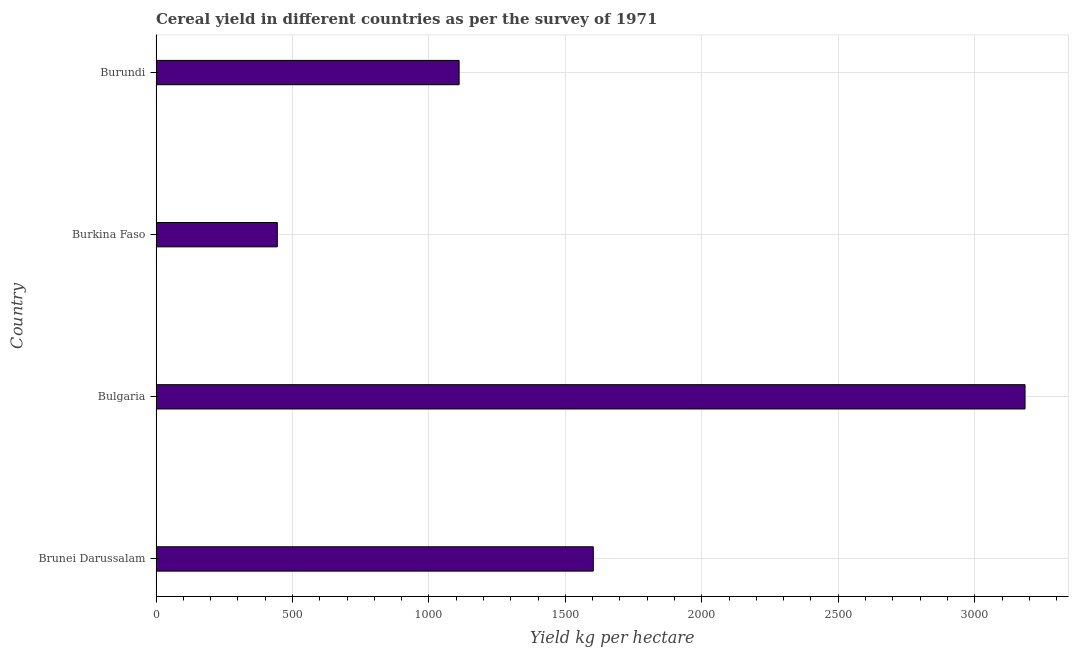Does the graph contain any zero values?
Give a very brief answer. No. What is the title of the graph?
Your answer should be compact. Cereal yield in different countries as per the survey of 1971. What is the label or title of the X-axis?
Ensure brevity in your answer.  Yield kg per hectare. What is the label or title of the Y-axis?
Your answer should be compact. Country. What is the cereal yield in Burkina Faso?
Offer a terse response. 444.45. Across all countries, what is the maximum cereal yield?
Offer a very short reply. 3184.4. Across all countries, what is the minimum cereal yield?
Your answer should be compact. 444.45. In which country was the cereal yield minimum?
Offer a terse response. Burkina Faso. What is the sum of the cereal yield?
Give a very brief answer. 6341.92. What is the difference between the cereal yield in Brunei Darussalam and Burkina Faso?
Give a very brief answer. 1157.96. What is the average cereal yield per country?
Provide a short and direct response. 1585.48. What is the median cereal yield?
Your answer should be compact. 1356.54. In how many countries, is the cereal yield greater than 200 kg per hectare?
Offer a terse response. 4. What is the ratio of the cereal yield in Bulgaria to that in Burkina Faso?
Make the answer very short. 7.17. Is the cereal yield in Brunei Darussalam less than that in Burkina Faso?
Provide a short and direct response. No. Is the difference between the cereal yield in Brunei Darussalam and Burkina Faso greater than the difference between any two countries?
Your response must be concise. No. What is the difference between the highest and the second highest cereal yield?
Provide a succinct answer. 1581.98. Is the sum of the cereal yield in Burkina Faso and Burundi greater than the maximum cereal yield across all countries?
Make the answer very short. No. What is the difference between the highest and the lowest cereal yield?
Offer a terse response. 2739.95. In how many countries, is the cereal yield greater than the average cereal yield taken over all countries?
Make the answer very short. 2. Are all the bars in the graph horizontal?
Provide a succinct answer. Yes. Are the values on the major ticks of X-axis written in scientific E-notation?
Your response must be concise. No. What is the Yield kg per hectare of Brunei Darussalam?
Ensure brevity in your answer.  1602.41. What is the Yield kg per hectare in Bulgaria?
Make the answer very short. 3184.4. What is the Yield kg per hectare of Burkina Faso?
Offer a terse response. 444.45. What is the Yield kg per hectare in Burundi?
Your answer should be compact. 1110.66. What is the difference between the Yield kg per hectare in Brunei Darussalam and Bulgaria?
Your answer should be compact. -1581.98. What is the difference between the Yield kg per hectare in Brunei Darussalam and Burkina Faso?
Give a very brief answer. 1157.96. What is the difference between the Yield kg per hectare in Brunei Darussalam and Burundi?
Your response must be concise. 491.76. What is the difference between the Yield kg per hectare in Bulgaria and Burkina Faso?
Ensure brevity in your answer.  2739.95. What is the difference between the Yield kg per hectare in Bulgaria and Burundi?
Your answer should be very brief. 2073.74. What is the difference between the Yield kg per hectare in Burkina Faso and Burundi?
Your answer should be compact. -666.21. What is the ratio of the Yield kg per hectare in Brunei Darussalam to that in Bulgaria?
Provide a succinct answer. 0.5. What is the ratio of the Yield kg per hectare in Brunei Darussalam to that in Burkina Faso?
Keep it short and to the point. 3.6. What is the ratio of the Yield kg per hectare in Brunei Darussalam to that in Burundi?
Offer a terse response. 1.44. What is the ratio of the Yield kg per hectare in Bulgaria to that in Burkina Faso?
Your answer should be very brief. 7.17. What is the ratio of the Yield kg per hectare in Bulgaria to that in Burundi?
Provide a succinct answer. 2.87. What is the ratio of the Yield kg per hectare in Burkina Faso to that in Burundi?
Your response must be concise. 0.4. 